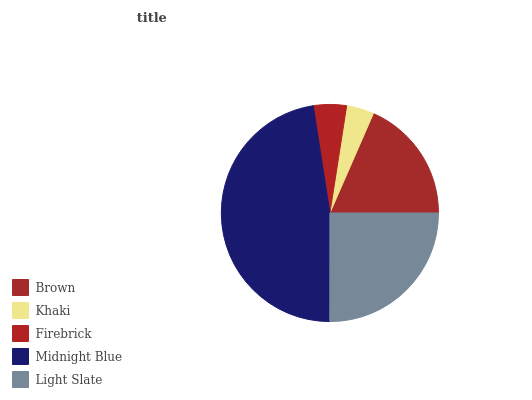Is Khaki the minimum?
Answer yes or no. Yes. Is Midnight Blue the maximum?
Answer yes or no. Yes. Is Firebrick the minimum?
Answer yes or no. No. Is Firebrick the maximum?
Answer yes or no. No. Is Firebrick greater than Khaki?
Answer yes or no. Yes. Is Khaki less than Firebrick?
Answer yes or no. Yes. Is Khaki greater than Firebrick?
Answer yes or no. No. Is Firebrick less than Khaki?
Answer yes or no. No. Is Brown the high median?
Answer yes or no. Yes. Is Brown the low median?
Answer yes or no. Yes. Is Firebrick the high median?
Answer yes or no. No. Is Firebrick the low median?
Answer yes or no. No. 